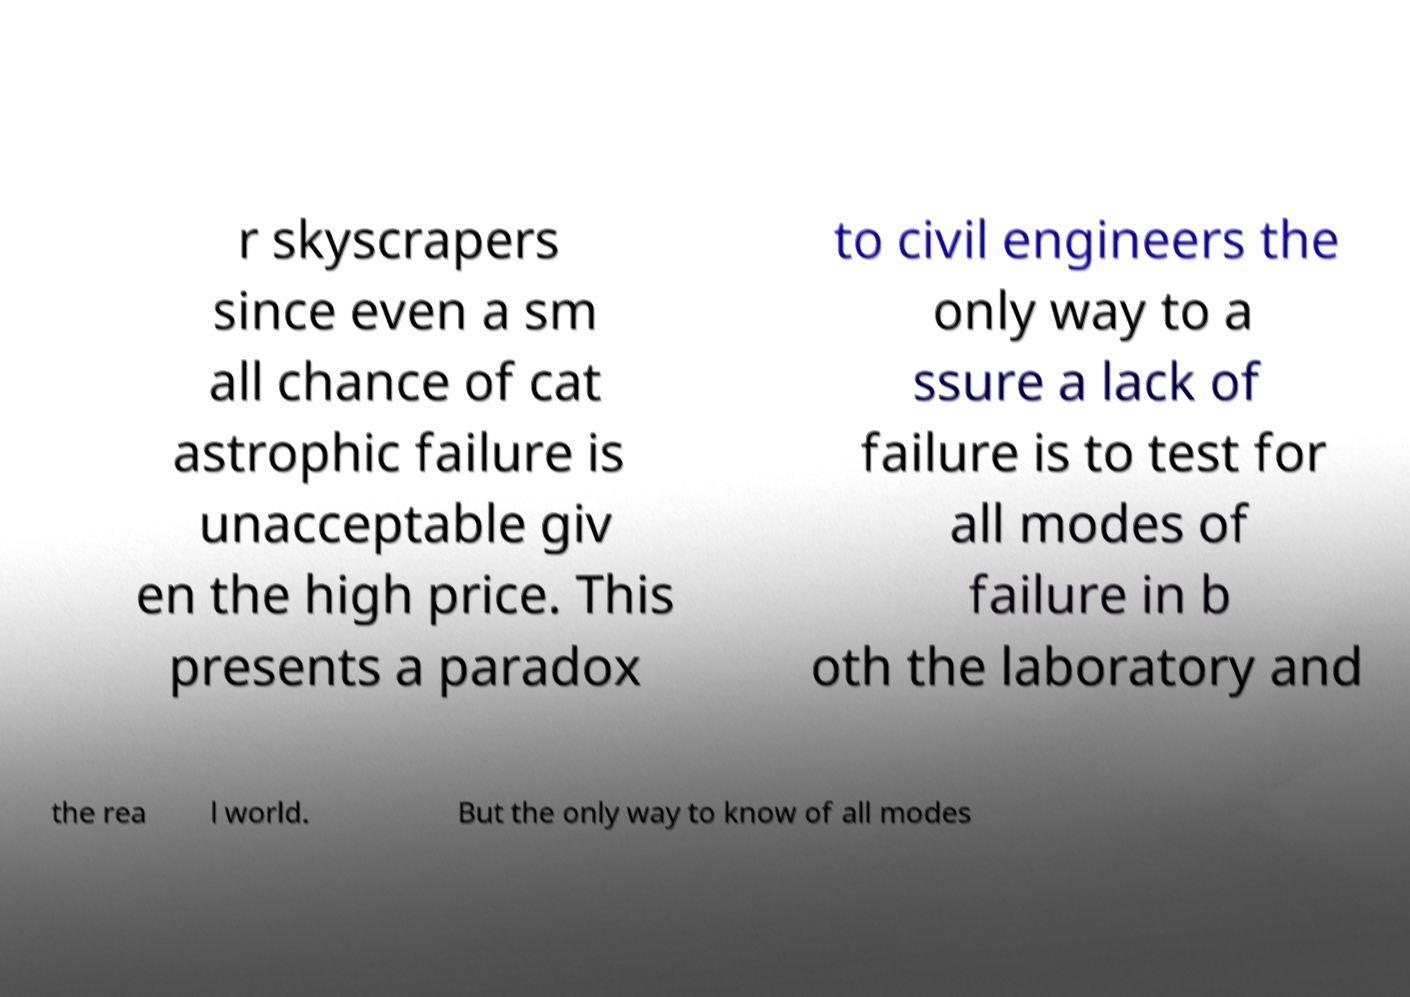Could you assist in decoding the text presented in this image and type it out clearly? r skyscrapers since even a sm all chance of cat astrophic failure is unacceptable giv en the high price. This presents a paradox to civil engineers the only way to a ssure a lack of failure is to test for all modes of failure in b oth the laboratory and the rea l world. But the only way to know of all modes 